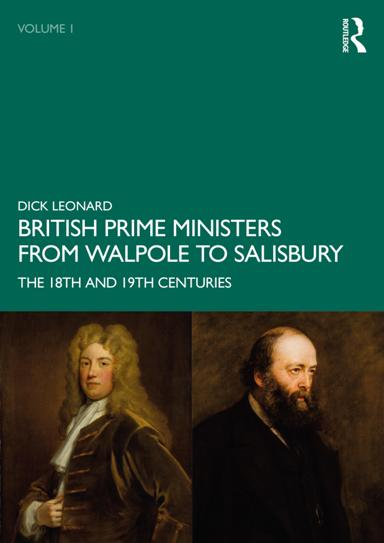What time periods does the book cover? The book spans the 18th and 19th centuries, detailing the lives and impacts of key figures in British political history during this era, which was marked by significant transformations in governance and society. 